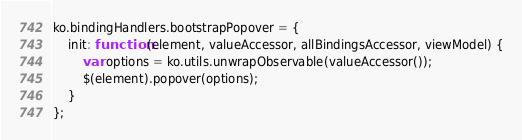<code> <loc_0><loc_0><loc_500><loc_500><_JavaScript_>ko.bindingHandlers.bootstrapPopover = {
    init: function (element, valueAccessor, allBindingsAccessor, viewModel) {
        var options = ko.utils.unwrapObservable(valueAccessor());
        $(element).popover(options);
    }
};</code> 